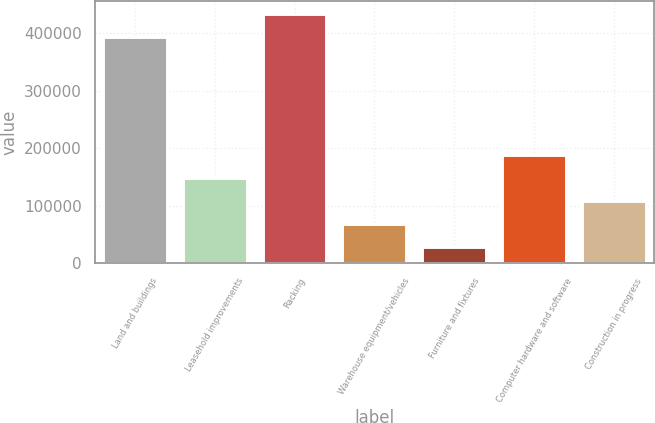Convert chart. <chart><loc_0><loc_0><loc_500><loc_500><bar_chart><fcel>Land and buildings<fcel>Leasehold improvements<fcel>Racking<fcel>Warehouse equipment/vehicles<fcel>Furniture and fixtures<fcel>Computer hardware and software<fcel>Construction in progress<nl><fcel>393429<fcel>148369<fcel>433201<fcel>68824.4<fcel>29052<fcel>188142<fcel>108597<nl></chart> 